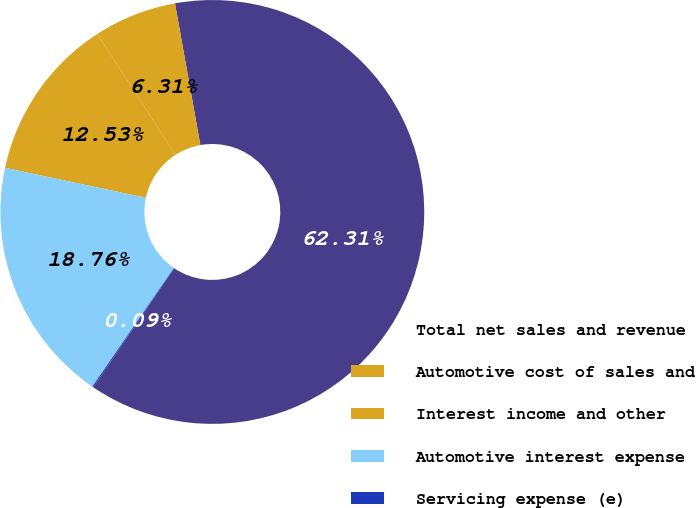Convert chart. <chart><loc_0><loc_0><loc_500><loc_500><pie_chart><fcel>Total net sales and revenue<fcel>Automotive cost of sales and<fcel>Interest income and other<fcel>Automotive interest expense<fcel>Servicing expense (e)<nl><fcel>62.31%<fcel>6.31%<fcel>12.53%<fcel>18.76%<fcel>0.09%<nl></chart> 